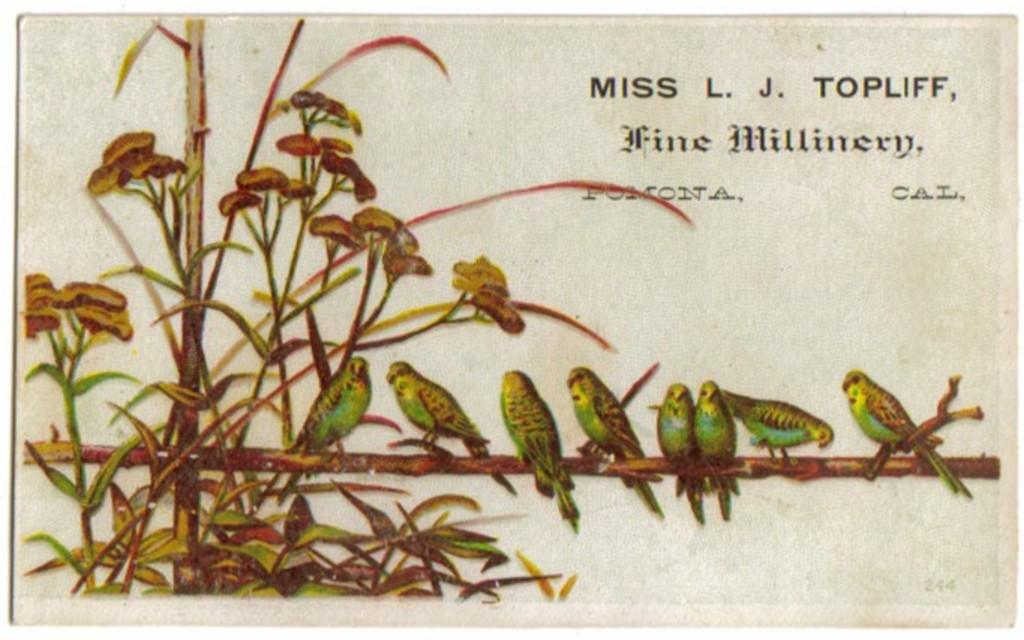What is the main subject of the image? There is a painting in the image. What is depicted in the painting? There are birds standing on a stick in the painting. What else can be seen in the painting? There is a plant on the left side of the painting. Are there any words or letters in the painting? Yes, there are texts on the top of the painting. What type of throat lozenges are visible in the painting? There are no throat lozenges present in the painting; it features birds, a stick, a plant, and texts. 